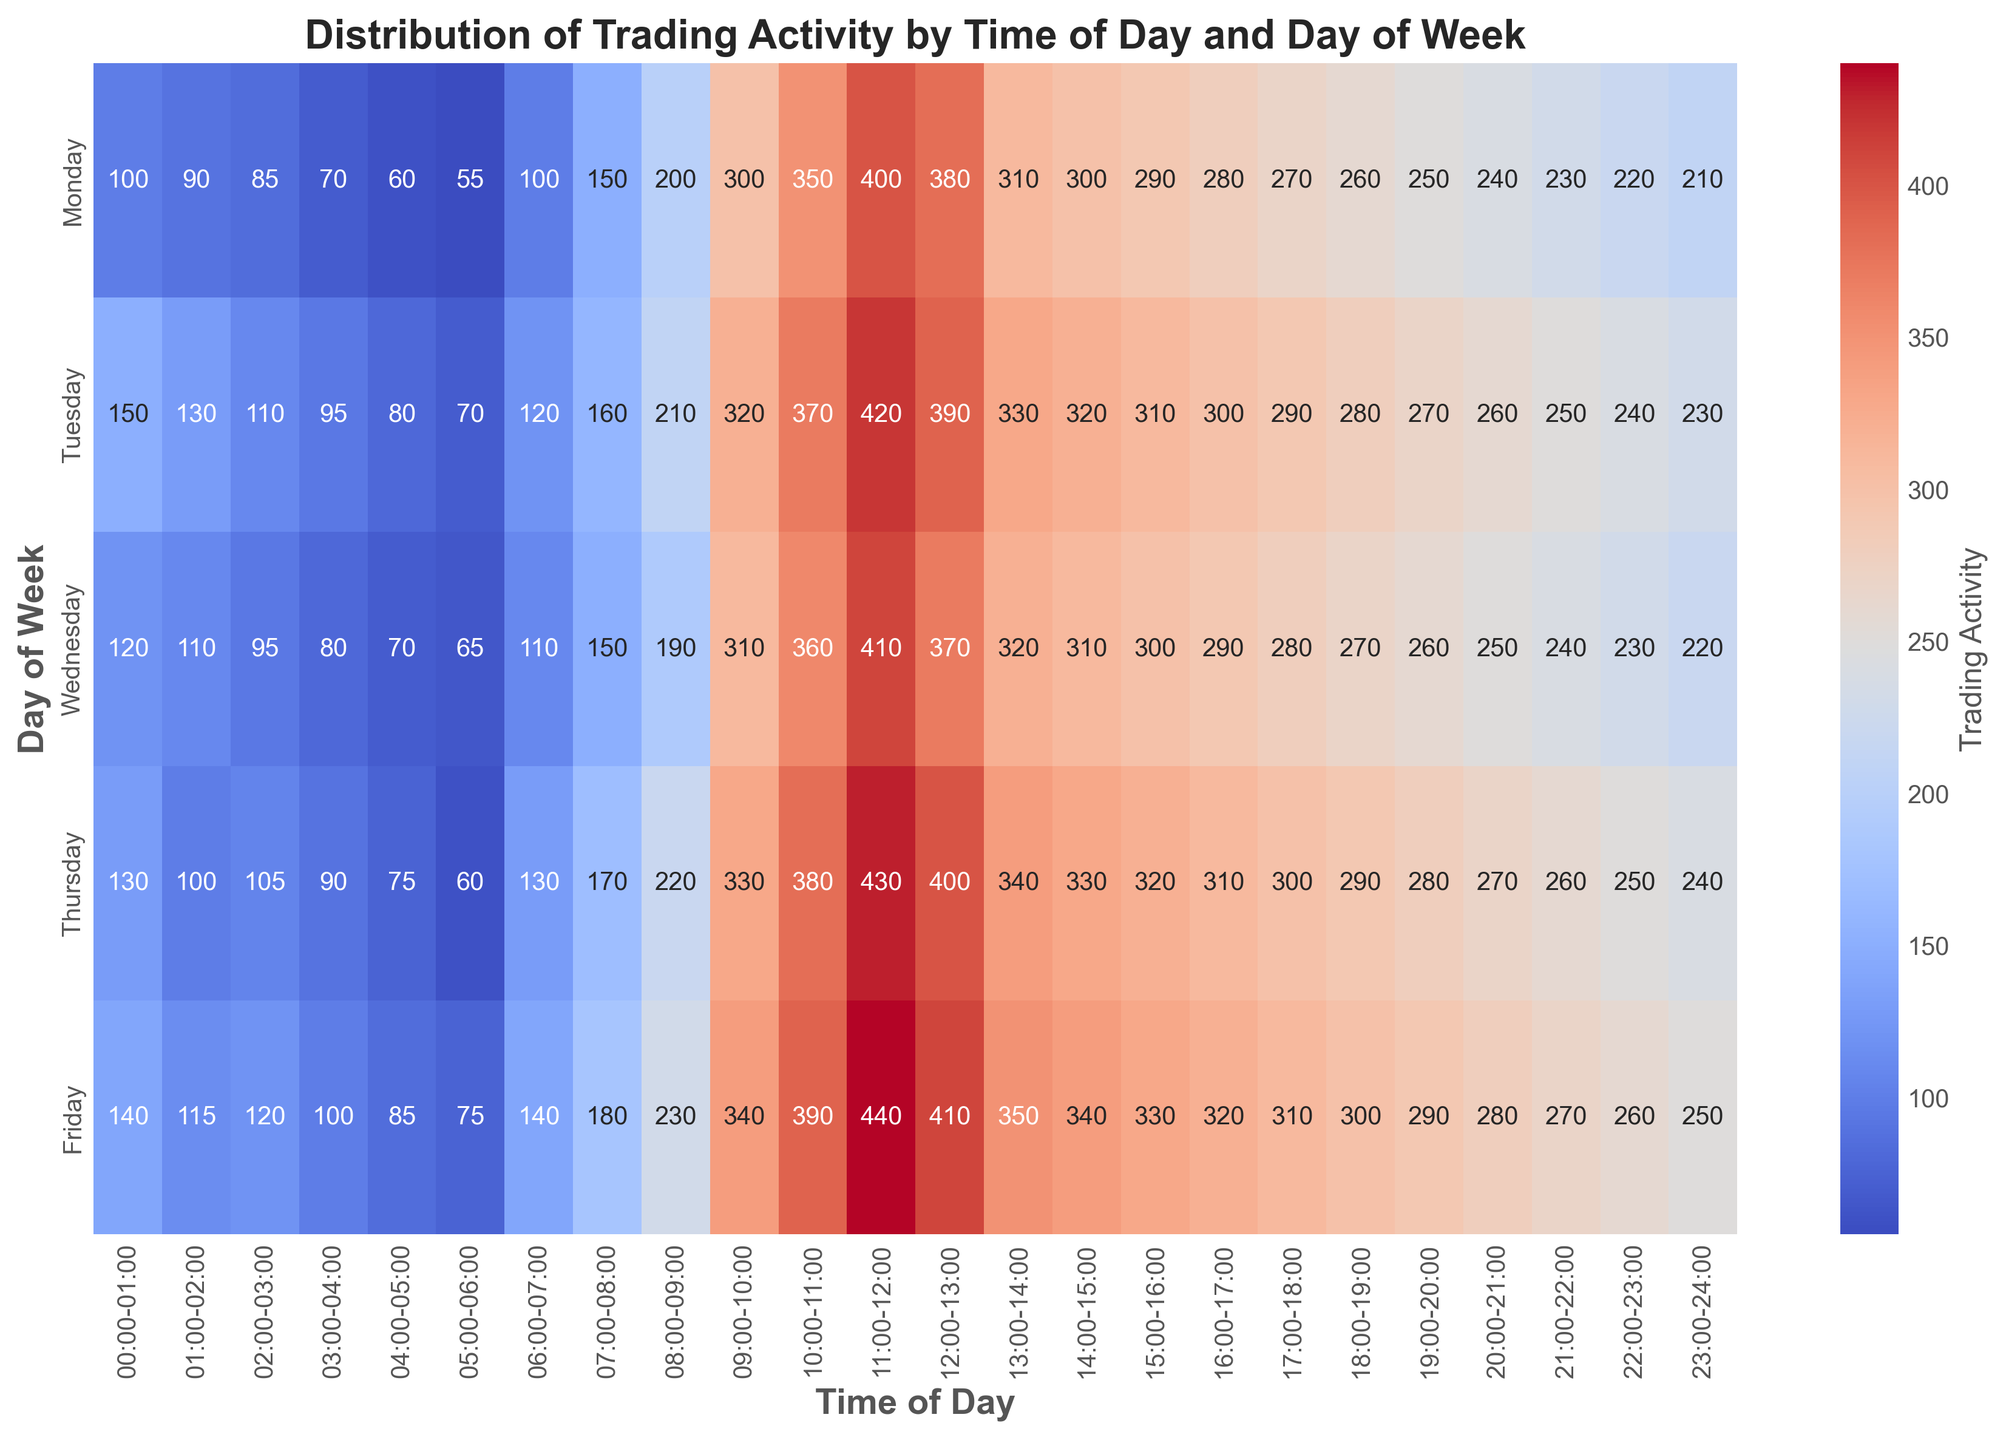what time of day has the highest trading activity on Friday? By looking at the heatmap, identify the darkest (most intense) color square on the row for Friday, which represents the highest number value, and check the corresponding time on the x-axis. The darkest square on Friday is at the time 11:00-12:00.
Answer: 11:00-12:00 During which time slot does Tuesday have the lowest trading activity? To find the lowest trading activity on Tuesday, look for the lightest (least intense) color square in the row for Tuesday and check the corresponding time on the x-axis. The lightest square for Tuesday is at the time 05:00-06:00.
Answer: 05:00-06:00 What is the average trading activity for 09:00-10:00, across all days? To calculate the average trading activity during 09:00-10:00, sum the trading activity figures for all days and divide by the number of days: (300 + 320 + 310 + 330 + 340) / 5 = 320.
Answer: 320 Which day has the highest trading activity at 15:00-16:00? To determine the highest trading activity at 15:00-16:00, compare the numbers in the column for this time slot across all days. The highest value at 15:00-16:00 is 330 on Friday.
Answer: Friday Between 12:00-13:00 on Monday and 19:00-20:00 on Friday, which period has higher trading activity on average? Calculate the average for trading activity in each period first: Monday 12:00-13:00 is 380, and Friday 19:00-20:00 is 290. Thus, 380 > 290.
Answer: 12:00-13:00 on Monday How does the trading activity at 07:00-08:00 on Thursday compare to the same time slot on Tuesday? Check the trading activity figures for 07:00-08:00 on Thursday and Tuesday, which are 170 and 160 respectively. Hence, Thursday has higher trading activity than Tuesday at that time slot.
Answer: Higher on Thursday What is the total trading activity on Wednesday from 02:00 to 04:00? Add the trading activity values for Wednesday between 02:00 and 04:00. The values are 95 between 02:00-03:00 and 80 between 03:00-04:00, giving a total of 95 + 80 = 175.
Answer: 175 Compare trading activities between 08:00-09:00 and 16:00-17:00 on Monday, which slot has higher activity? Check the trading activity values for each slot on Monday: 08:00-09:00 is 200 and 16:00-17:00 is 280. Thus, 16:00-17:00 has higher trading activity.
Answer: 16:00-17:00 Identify the time slot on Monday with the second highest trading activity. Look for the second darkest color square in the Monday row after identifying the darkest one (which is 10:00-11:00 with 350), the second darkest is 11:00-12:00 with 400.
Answer: 11:00-12:00 What is the average trading activity between 10:00-11:00 from Monday to Friday, and how does it compare to the average from 13:00-14:00 for the same period? Calculate the averages: 10:00-11:00 includes (350 + 370 + 360 + 380 + 390) / 5 = 370, and 13:00-14:00 includes (310 + 330 + 320 + 340 + 350) / 5 = 330. Therefore, 370 is higher than 330.
Answer: Higher for 10:00-11:00 